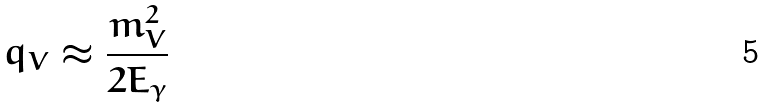Convert formula to latex. <formula><loc_0><loc_0><loc_500><loc_500>q _ { V } \approx \frac { m _ { V } ^ { 2 } } { 2 E _ { \gamma } }</formula> 